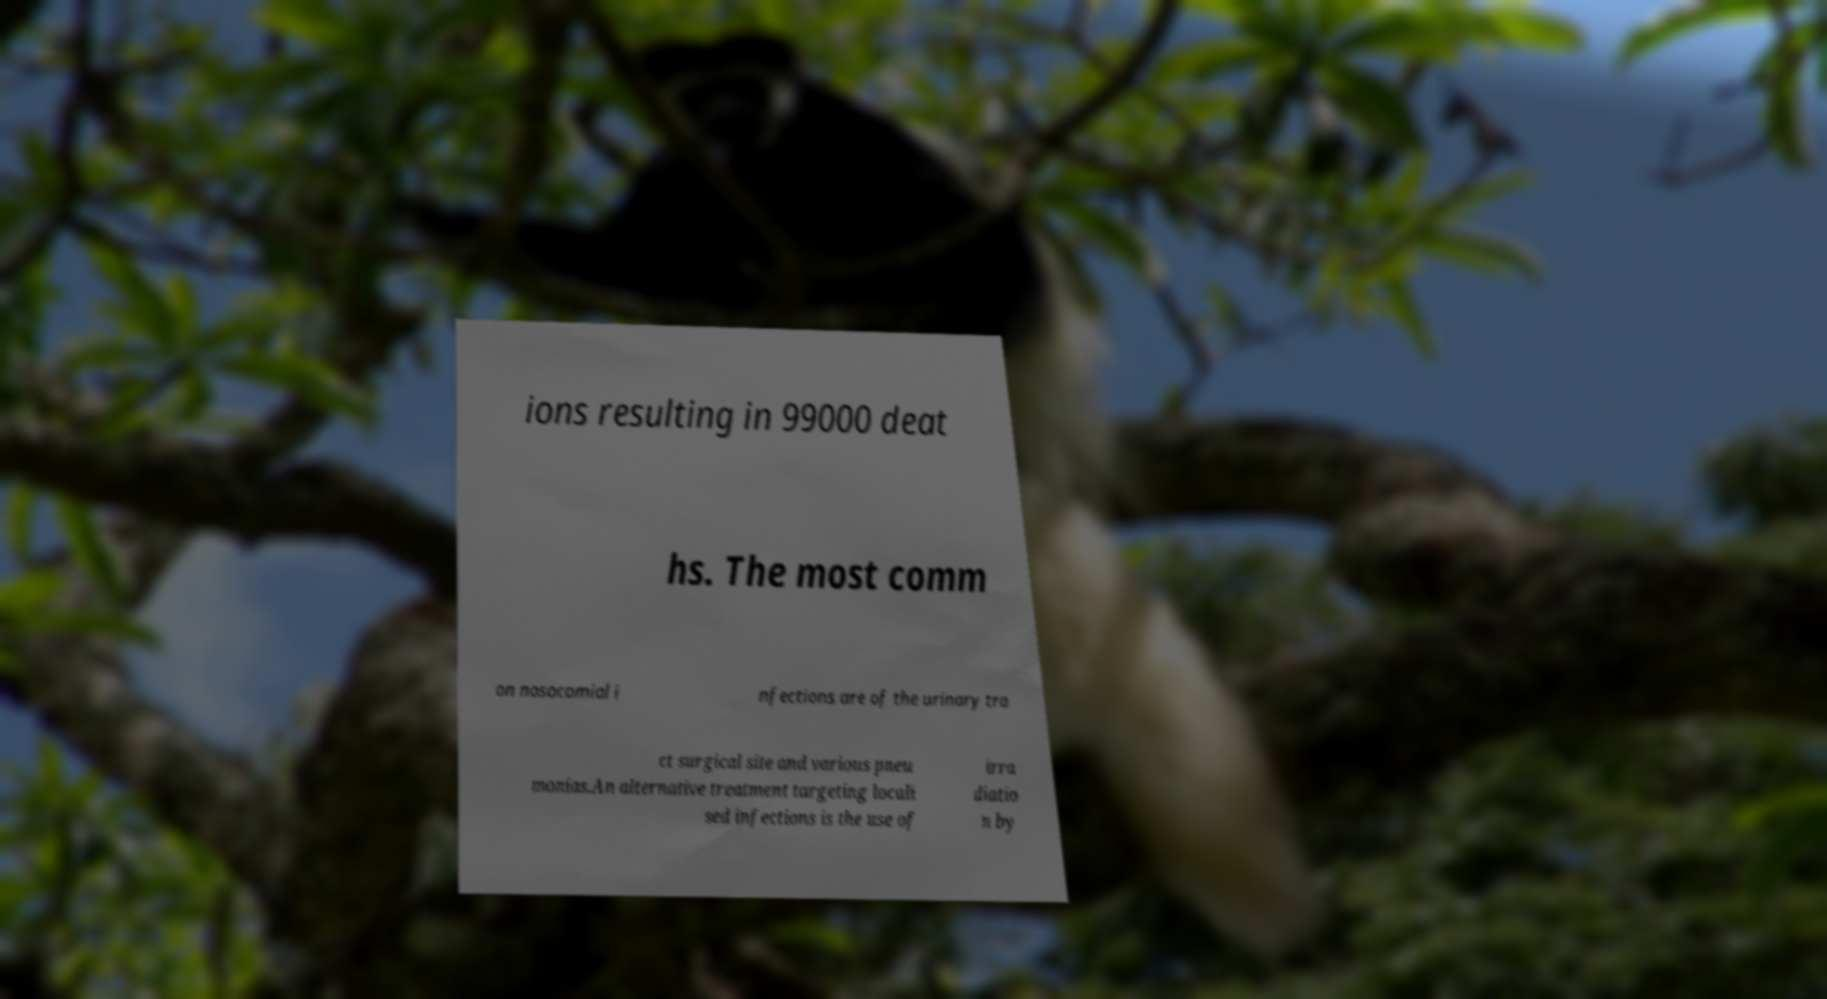Could you assist in decoding the text presented in this image and type it out clearly? ions resulting in 99000 deat hs. The most comm on nosocomial i nfections are of the urinary tra ct surgical site and various pneu monias.An alternative treatment targeting locali sed infections is the use of irra diatio n by 